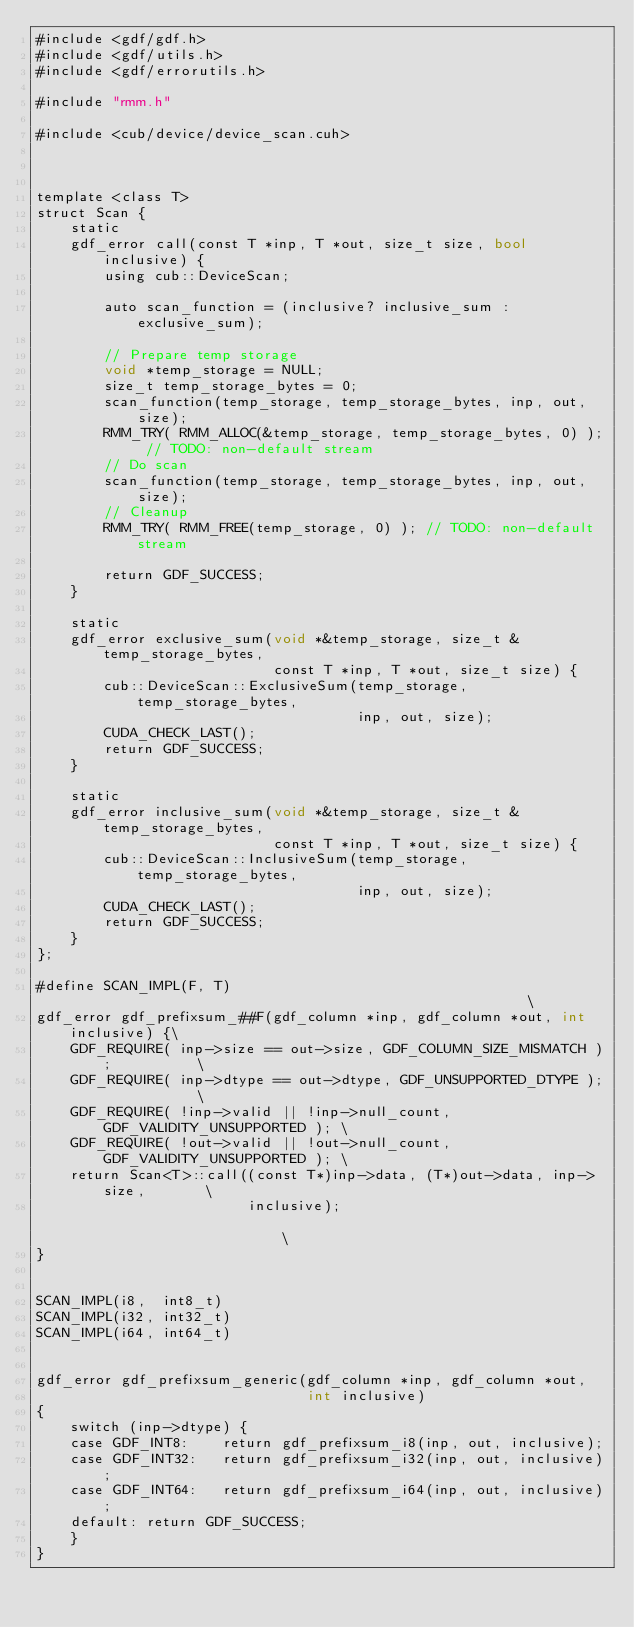Convert code to text. <code><loc_0><loc_0><loc_500><loc_500><_Cuda_>#include <gdf/gdf.h>
#include <gdf/utils.h>
#include <gdf/errorutils.h>

#include "rmm.h"

#include <cub/device/device_scan.cuh>



template <class T>
struct Scan {
    static
    gdf_error call(const T *inp, T *out, size_t size, bool inclusive) {
        using cub::DeviceScan;

        auto scan_function = (inclusive? inclusive_sum : exclusive_sum);

        // Prepare temp storage
        void *temp_storage = NULL;
        size_t temp_storage_bytes = 0;
        scan_function(temp_storage, temp_storage_bytes, inp, out, size);
        RMM_TRY( RMM_ALLOC(&temp_storage, temp_storage_bytes, 0) ); // TODO: non-default stream
        // Do scan
        scan_function(temp_storage, temp_storage_bytes, inp, out, size);
        // Cleanup
        RMM_TRY( RMM_FREE(temp_storage, 0) ); // TODO: non-default stream

        return GDF_SUCCESS;
    }

    static
    gdf_error exclusive_sum(void *&temp_storage, size_t &temp_storage_bytes,
                            const T *inp, T *out, size_t size) {
        cub::DeviceScan::ExclusiveSum(temp_storage, temp_storage_bytes,
                                      inp, out, size);
        CUDA_CHECK_LAST();
        return GDF_SUCCESS;
    }

    static
    gdf_error inclusive_sum(void *&temp_storage, size_t &temp_storage_bytes,
                            const T *inp, T *out, size_t size) {
        cub::DeviceScan::InclusiveSum(temp_storage, temp_storage_bytes,
                                      inp, out, size);
        CUDA_CHECK_LAST();
        return GDF_SUCCESS;
    }
};

#define SCAN_IMPL(F, T)                                                       \
gdf_error gdf_prefixsum_##F(gdf_column *inp, gdf_column *out, int inclusive) {\
    GDF_REQUIRE( inp->size == out->size, GDF_COLUMN_SIZE_MISMATCH );          \
    GDF_REQUIRE( inp->dtype == out->dtype, GDF_UNSUPPORTED_DTYPE );           \
    GDF_REQUIRE( !inp->valid || !inp->null_count, GDF_VALIDITY_UNSUPPORTED ); \
    GDF_REQUIRE( !out->valid || !out->null_count, GDF_VALIDITY_UNSUPPORTED ); \
    return Scan<T>::call((const T*)inp->data, (T*)out->data, inp->size,       \
                         inclusive);                                          \
}


SCAN_IMPL(i8,  int8_t)
SCAN_IMPL(i32, int32_t)
SCAN_IMPL(i64, int64_t)


gdf_error gdf_prefixsum_generic(gdf_column *inp, gdf_column *out,
                                int inclusive)
{
    switch (inp->dtype) {
    case GDF_INT8:    return gdf_prefixsum_i8(inp, out, inclusive);
    case GDF_INT32:   return gdf_prefixsum_i32(inp, out, inclusive);
    case GDF_INT64:   return gdf_prefixsum_i64(inp, out, inclusive);
    default: return GDF_SUCCESS;
    }
}
</code> 